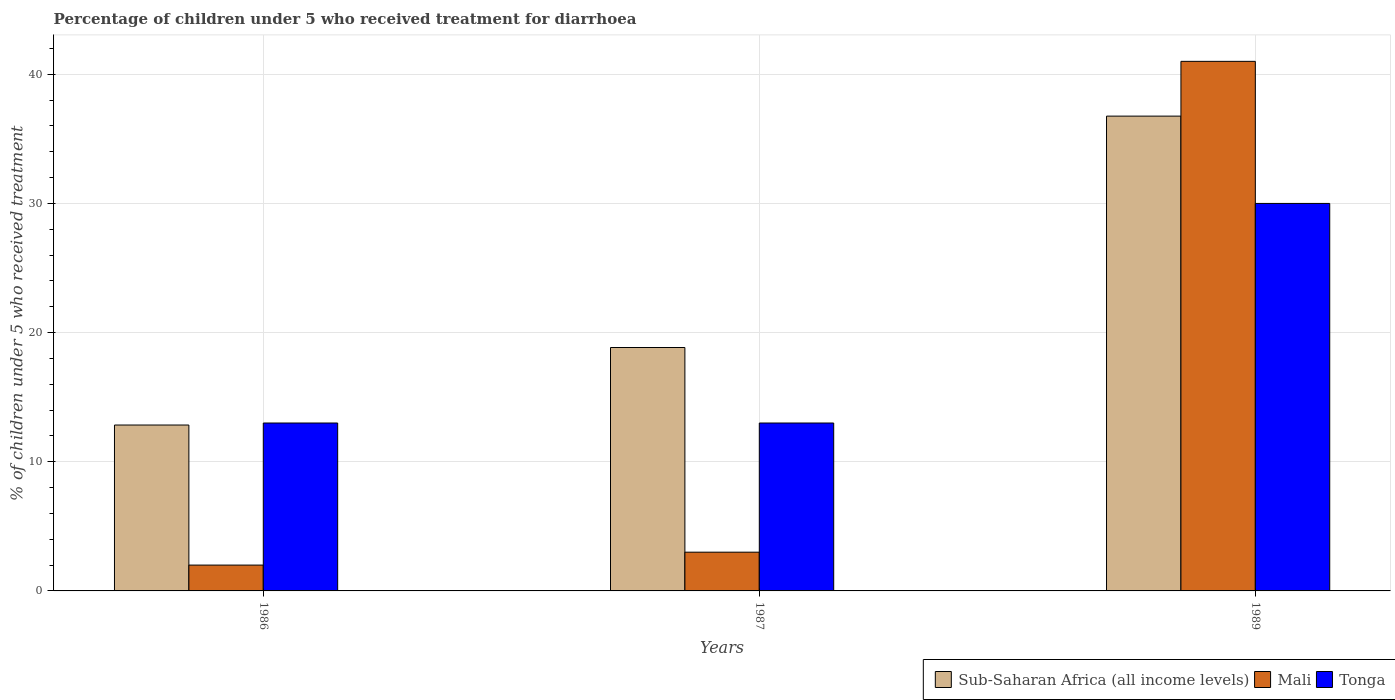How many groups of bars are there?
Your answer should be very brief. 3. Are the number of bars per tick equal to the number of legend labels?
Offer a very short reply. Yes. Are the number of bars on each tick of the X-axis equal?
Your answer should be very brief. Yes. How many bars are there on the 3rd tick from the left?
Your answer should be very brief. 3. How many bars are there on the 3rd tick from the right?
Make the answer very short. 3. Across all years, what is the maximum percentage of children who received treatment for diarrhoea  in Sub-Saharan Africa (all income levels)?
Offer a terse response. 36.76. Across all years, what is the minimum percentage of children who received treatment for diarrhoea  in Sub-Saharan Africa (all income levels)?
Provide a short and direct response. 12.84. What is the total percentage of children who received treatment for diarrhoea  in Tonga in the graph?
Ensure brevity in your answer.  56. What is the difference between the percentage of children who received treatment for diarrhoea  in Sub-Saharan Africa (all income levels) in 1986 and that in 1987?
Make the answer very short. -6. What is the difference between the percentage of children who received treatment for diarrhoea  in Tonga in 1987 and the percentage of children who received treatment for diarrhoea  in Sub-Saharan Africa (all income levels) in 1989?
Provide a short and direct response. -23.76. What is the average percentage of children who received treatment for diarrhoea  in Sub-Saharan Africa (all income levels) per year?
Offer a terse response. 22.82. In the year 1987, what is the difference between the percentage of children who received treatment for diarrhoea  in Mali and percentage of children who received treatment for diarrhoea  in Sub-Saharan Africa (all income levels)?
Provide a short and direct response. -15.85. What is the ratio of the percentage of children who received treatment for diarrhoea  in Tonga in 1987 to that in 1989?
Offer a terse response. 0.43. Is the percentage of children who received treatment for diarrhoea  in Tonga in 1986 less than that in 1987?
Offer a terse response. No. What is the difference between the highest and the lowest percentage of children who received treatment for diarrhoea  in Sub-Saharan Africa (all income levels)?
Provide a succinct answer. 23.92. In how many years, is the percentage of children who received treatment for diarrhoea  in Tonga greater than the average percentage of children who received treatment for diarrhoea  in Tonga taken over all years?
Your response must be concise. 1. Is the sum of the percentage of children who received treatment for diarrhoea  in Tonga in 1986 and 1989 greater than the maximum percentage of children who received treatment for diarrhoea  in Sub-Saharan Africa (all income levels) across all years?
Provide a short and direct response. Yes. What does the 1st bar from the left in 1987 represents?
Make the answer very short. Sub-Saharan Africa (all income levels). What does the 2nd bar from the right in 1989 represents?
Your response must be concise. Mali. Are all the bars in the graph horizontal?
Give a very brief answer. No. How many legend labels are there?
Make the answer very short. 3. What is the title of the graph?
Your answer should be compact. Percentage of children under 5 who received treatment for diarrhoea. Does "European Union" appear as one of the legend labels in the graph?
Make the answer very short. No. What is the label or title of the Y-axis?
Your answer should be very brief. % of children under 5 who received treatment. What is the % of children under 5 who received treatment in Sub-Saharan Africa (all income levels) in 1986?
Keep it short and to the point. 12.84. What is the % of children under 5 who received treatment of Tonga in 1986?
Provide a succinct answer. 13. What is the % of children under 5 who received treatment of Sub-Saharan Africa (all income levels) in 1987?
Offer a terse response. 18.85. What is the % of children under 5 who received treatment of Tonga in 1987?
Your answer should be very brief. 13. What is the % of children under 5 who received treatment in Sub-Saharan Africa (all income levels) in 1989?
Your response must be concise. 36.76. Across all years, what is the maximum % of children under 5 who received treatment of Sub-Saharan Africa (all income levels)?
Your response must be concise. 36.76. Across all years, what is the minimum % of children under 5 who received treatment in Sub-Saharan Africa (all income levels)?
Ensure brevity in your answer.  12.84. What is the total % of children under 5 who received treatment in Sub-Saharan Africa (all income levels) in the graph?
Your answer should be very brief. 68.45. What is the total % of children under 5 who received treatment of Tonga in the graph?
Your response must be concise. 56. What is the difference between the % of children under 5 who received treatment in Sub-Saharan Africa (all income levels) in 1986 and that in 1987?
Provide a succinct answer. -6. What is the difference between the % of children under 5 who received treatment in Tonga in 1986 and that in 1987?
Ensure brevity in your answer.  0. What is the difference between the % of children under 5 who received treatment in Sub-Saharan Africa (all income levels) in 1986 and that in 1989?
Your answer should be compact. -23.92. What is the difference between the % of children under 5 who received treatment of Mali in 1986 and that in 1989?
Your response must be concise. -39. What is the difference between the % of children under 5 who received treatment of Tonga in 1986 and that in 1989?
Offer a very short reply. -17. What is the difference between the % of children under 5 who received treatment in Sub-Saharan Africa (all income levels) in 1987 and that in 1989?
Make the answer very short. -17.91. What is the difference between the % of children under 5 who received treatment in Mali in 1987 and that in 1989?
Make the answer very short. -38. What is the difference between the % of children under 5 who received treatment in Tonga in 1987 and that in 1989?
Offer a very short reply. -17. What is the difference between the % of children under 5 who received treatment in Sub-Saharan Africa (all income levels) in 1986 and the % of children under 5 who received treatment in Mali in 1987?
Your answer should be very brief. 9.84. What is the difference between the % of children under 5 who received treatment of Sub-Saharan Africa (all income levels) in 1986 and the % of children under 5 who received treatment of Tonga in 1987?
Make the answer very short. -0.16. What is the difference between the % of children under 5 who received treatment of Mali in 1986 and the % of children under 5 who received treatment of Tonga in 1987?
Keep it short and to the point. -11. What is the difference between the % of children under 5 who received treatment of Sub-Saharan Africa (all income levels) in 1986 and the % of children under 5 who received treatment of Mali in 1989?
Provide a succinct answer. -28.16. What is the difference between the % of children under 5 who received treatment of Sub-Saharan Africa (all income levels) in 1986 and the % of children under 5 who received treatment of Tonga in 1989?
Give a very brief answer. -17.16. What is the difference between the % of children under 5 who received treatment of Mali in 1986 and the % of children under 5 who received treatment of Tonga in 1989?
Your answer should be very brief. -28. What is the difference between the % of children under 5 who received treatment in Sub-Saharan Africa (all income levels) in 1987 and the % of children under 5 who received treatment in Mali in 1989?
Offer a very short reply. -22.15. What is the difference between the % of children under 5 who received treatment of Sub-Saharan Africa (all income levels) in 1987 and the % of children under 5 who received treatment of Tonga in 1989?
Keep it short and to the point. -11.15. What is the difference between the % of children under 5 who received treatment in Mali in 1987 and the % of children under 5 who received treatment in Tonga in 1989?
Provide a succinct answer. -27. What is the average % of children under 5 who received treatment in Sub-Saharan Africa (all income levels) per year?
Your response must be concise. 22.82. What is the average % of children under 5 who received treatment of Mali per year?
Provide a short and direct response. 15.33. What is the average % of children under 5 who received treatment of Tonga per year?
Your answer should be very brief. 18.67. In the year 1986, what is the difference between the % of children under 5 who received treatment of Sub-Saharan Africa (all income levels) and % of children under 5 who received treatment of Mali?
Ensure brevity in your answer.  10.84. In the year 1986, what is the difference between the % of children under 5 who received treatment of Sub-Saharan Africa (all income levels) and % of children under 5 who received treatment of Tonga?
Give a very brief answer. -0.16. In the year 1986, what is the difference between the % of children under 5 who received treatment in Mali and % of children under 5 who received treatment in Tonga?
Provide a succinct answer. -11. In the year 1987, what is the difference between the % of children under 5 who received treatment of Sub-Saharan Africa (all income levels) and % of children under 5 who received treatment of Mali?
Provide a short and direct response. 15.85. In the year 1987, what is the difference between the % of children under 5 who received treatment of Sub-Saharan Africa (all income levels) and % of children under 5 who received treatment of Tonga?
Give a very brief answer. 5.85. In the year 1987, what is the difference between the % of children under 5 who received treatment in Mali and % of children under 5 who received treatment in Tonga?
Ensure brevity in your answer.  -10. In the year 1989, what is the difference between the % of children under 5 who received treatment in Sub-Saharan Africa (all income levels) and % of children under 5 who received treatment in Mali?
Provide a succinct answer. -4.24. In the year 1989, what is the difference between the % of children under 5 who received treatment in Sub-Saharan Africa (all income levels) and % of children under 5 who received treatment in Tonga?
Offer a very short reply. 6.76. What is the ratio of the % of children under 5 who received treatment of Sub-Saharan Africa (all income levels) in 1986 to that in 1987?
Ensure brevity in your answer.  0.68. What is the ratio of the % of children under 5 who received treatment of Sub-Saharan Africa (all income levels) in 1986 to that in 1989?
Offer a terse response. 0.35. What is the ratio of the % of children under 5 who received treatment of Mali in 1986 to that in 1989?
Offer a terse response. 0.05. What is the ratio of the % of children under 5 who received treatment of Tonga in 1986 to that in 1989?
Provide a succinct answer. 0.43. What is the ratio of the % of children under 5 who received treatment of Sub-Saharan Africa (all income levels) in 1987 to that in 1989?
Make the answer very short. 0.51. What is the ratio of the % of children under 5 who received treatment of Mali in 1987 to that in 1989?
Offer a very short reply. 0.07. What is the ratio of the % of children under 5 who received treatment of Tonga in 1987 to that in 1989?
Make the answer very short. 0.43. What is the difference between the highest and the second highest % of children under 5 who received treatment in Sub-Saharan Africa (all income levels)?
Keep it short and to the point. 17.91. What is the difference between the highest and the second highest % of children under 5 who received treatment of Mali?
Offer a very short reply. 38. What is the difference between the highest and the second highest % of children under 5 who received treatment in Tonga?
Your answer should be compact. 17. What is the difference between the highest and the lowest % of children under 5 who received treatment of Sub-Saharan Africa (all income levels)?
Provide a succinct answer. 23.92. What is the difference between the highest and the lowest % of children under 5 who received treatment in Mali?
Your response must be concise. 39. 